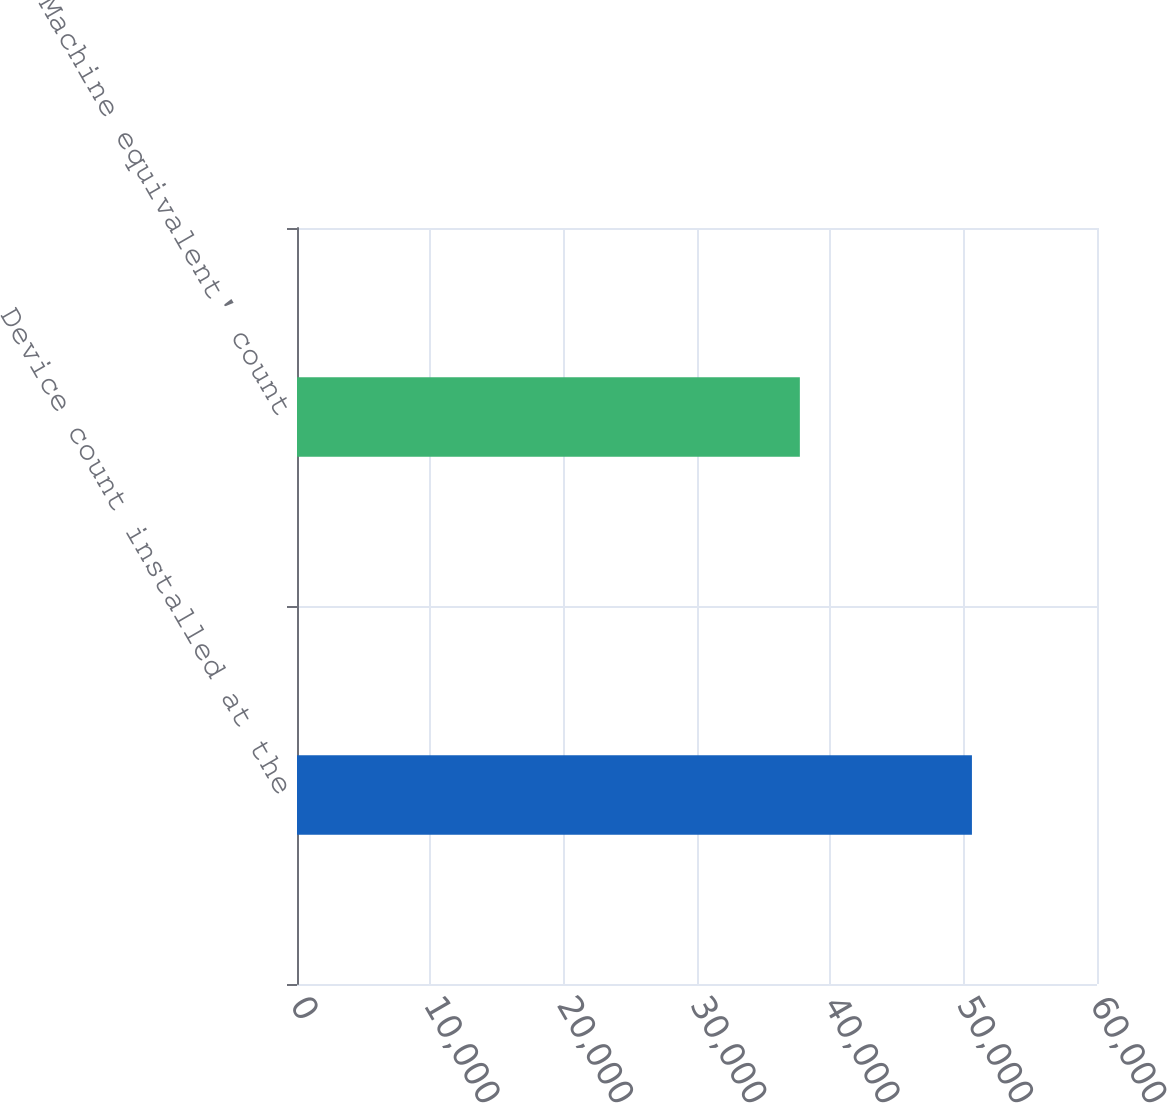Convert chart. <chart><loc_0><loc_0><loc_500><loc_500><bar_chart><fcel>Device count installed at the<fcel>'Machine equivalent' count<nl><fcel>50620<fcel>37714<nl></chart> 